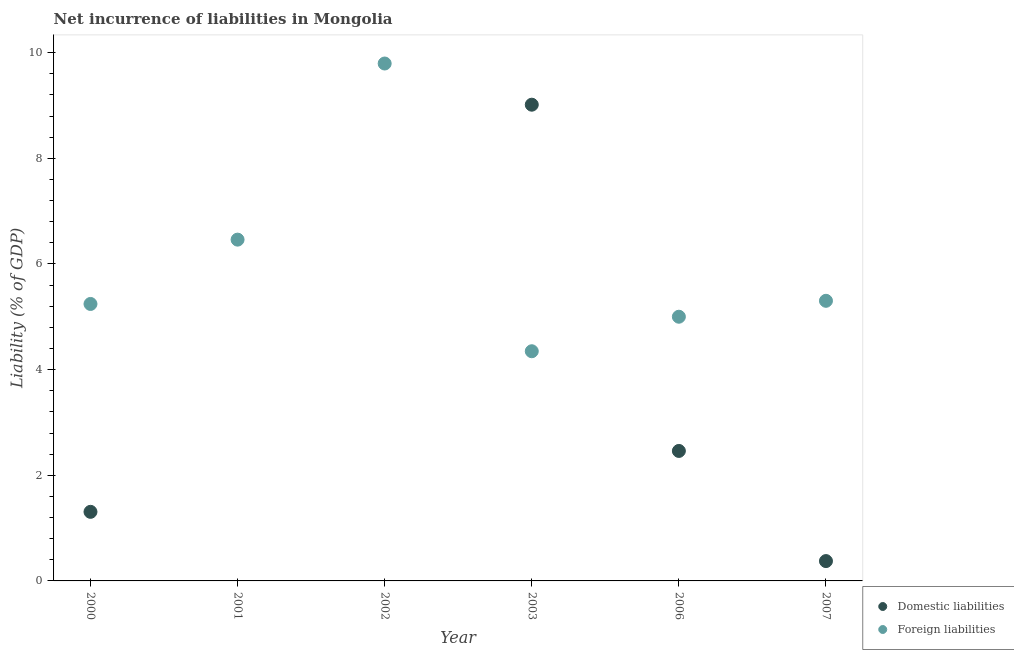How many different coloured dotlines are there?
Your answer should be very brief. 2. What is the incurrence of domestic liabilities in 2000?
Your answer should be very brief. 1.31. Across all years, what is the maximum incurrence of foreign liabilities?
Your answer should be compact. 9.79. What is the total incurrence of foreign liabilities in the graph?
Your answer should be compact. 36.15. What is the difference between the incurrence of domestic liabilities in 2003 and that in 2007?
Your answer should be compact. 8.64. What is the difference between the incurrence of domestic liabilities in 2003 and the incurrence of foreign liabilities in 2001?
Make the answer very short. 2.55. What is the average incurrence of domestic liabilities per year?
Your response must be concise. 2.19. In the year 2000, what is the difference between the incurrence of foreign liabilities and incurrence of domestic liabilities?
Make the answer very short. 3.94. In how many years, is the incurrence of foreign liabilities greater than 0.4 %?
Provide a succinct answer. 6. What is the ratio of the incurrence of foreign liabilities in 2000 to that in 2001?
Provide a succinct answer. 0.81. Is the incurrence of domestic liabilities in 2000 less than that in 2006?
Provide a short and direct response. Yes. What is the difference between the highest and the second highest incurrence of domestic liabilities?
Your response must be concise. 6.55. What is the difference between the highest and the lowest incurrence of domestic liabilities?
Provide a succinct answer. 9.02. In how many years, is the incurrence of domestic liabilities greater than the average incurrence of domestic liabilities taken over all years?
Provide a short and direct response. 2. Does the incurrence of foreign liabilities monotonically increase over the years?
Keep it short and to the point. No. Is the incurrence of foreign liabilities strictly greater than the incurrence of domestic liabilities over the years?
Give a very brief answer. No. What is the difference between two consecutive major ticks on the Y-axis?
Provide a short and direct response. 2. Does the graph contain any zero values?
Offer a very short reply. Yes. Where does the legend appear in the graph?
Offer a very short reply. Bottom right. How many legend labels are there?
Provide a short and direct response. 2. What is the title of the graph?
Offer a terse response. Net incurrence of liabilities in Mongolia. Does "Electricity" appear as one of the legend labels in the graph?
Offer a very short reply. No. What is the label or title of the Y-axis?
Offer a very short reply. Liability (% of GDP). What is the Liability (% of GDP) in Domestic liabilities in 2000?
Provide a succinct answer. 1.31. What is the Liability (% of GDP) in Foreign liabilities in 2000?
Give a very brief answer. 5.24. What is the Liability (% of GDP) in Foreign liabilities in 2001?
Your response must be concise. 6.46. What is the Liability (% of GDP) in Domestic liabilities in 2002?
Keep it short and to the point. 0. What is the Liability (% of GDP) of Foreign liabilities in 2002?
Keep it short and to the point. 9.79. What is the Liability (% of GDP) of Domestic liabilities in 2003?
Your response must be concise. 9.02. What is the Liability (% of GDP) of Foreign liabilities in 2003?
Give a very brief answer. 4.35. What is the Liability (% of GDP) in Domestic liabilities in 2006?
Give a very brief answer. 2.46. What is the Liability (% of GDP) in Foreign liabilities in 2006?
Your answer should be compact. 5. What is the Liability (% of GDP) in Domestic liabilities in 2007?
Make the answer very short. 0.38. What is the Liability (% of GDP) of Foreign liabilities in 2007?
Your answer should be very brief. 5.3. Across all years, what is the maximum Liability (% of GDP) of Domestic liabilities?
Your response must be concise. 9.02. Across all years, what is the maximum Liability (% of GDP) in Foreign liabilities?
Ensure brevity in your answer.  9.79. Across all years, what is the minimum Liability (% of GDP) in Domestic liabilities?
Provide a short and direct response. 0. Across all years, what is the minimum Liability (% of GDP) in Foreign liabilities?
Your response must be concise. 4.35. What is the total Liability (% of GDP) in Domestic liabilities in the graph?
Ensure brevity in your answer.  13.16. What is the total Liability (% of GDP) of Foreign liabilities in the graph?
Offer a very short reply. 36.15. What is the difference between the Liability (% of GDP) of Foreign liabilities in 2000 and that in 2001?
Your response must be concise. -1.22. What is the difference between the Liability (% of GDP) in Foreign liabilities in 2000 and that in 2002?
Make the answer very short. -4.55. What is the difference between the Liability (% of GDP) of Domestic liabilities in 2000 and that in 2003?
Offer a very short reply. -7.71. What is the difference between the Liability (% of GDP) of Foreign liabilities in 2000 and that in 2003?
Your answer should be very brief. 0.9. What is the difference between the Liability (% of GDP) of Domestic liabilities in 2000 and that in 2006?
Offer a very short reply. -1.15. What is the difference between the Liability (% of GDP) in Foreign liabilities in 2000 and that in 2006?
Ensure brevity in your answer.  0.24. What is the difference between the Liability (% of GDP) of Domestic liabilities in 2000 and that in 2007?
Provide a succinct answer. 0.93. What is the difference between the Liability (% of GDP) in Foreign liabilities in 2000 and that in 2007?
Your answer should be very brief. -0.06. What is the difference between the Liability (% of GDP) of Foreign liabilities in 2001 and that in 2002?
Your response must be concise. -3.33. What is the difference between the Liability (% of GDP) in Foreign liabilities in 2001 and that in 2003?
Offer a very short reply. 2.11. What is the difference between the Liability (% of GDP) of Foreign liabilities in 2001 and that in 2006?
Offer a very short reply. 1.46. What is the difference between the Liability (% of GDP) in Foreign liabilities in 2001 and that in 2007?
Your answer should be very brief. 1.16. What is the difference between the Liability (% of GDP) of Foreign liabilities in 2002 and that in 2003?
Make the answer very short. 5.45. What is the difference between the Liability (% of GDP) of Foreign liabilities in 2002 and that in 2006?
Make the answer very short. 4.79. What is the difference between the Liability (% of GDP) in Foreign liabilities in 2002 and that in 2007?
Ensure brevity in your answer.  4.49. What is the difference between the Liability (% of GDP) of Domestic liabilities in 2003 and that in 2006?
Give a very brief answer. 6.55. What is the difference between the Liability (% of GDP) in Foreign liabilities in 2003 and that in 2006?
Provide a short and direct response. -0.65. What is the difference between the Liability (% of GDP) of Domestic liabilities in 2003 and that in 2007?
Your answer should be very brief. 8.64. What is the difference between the Liability (% of GDP) of Foreign liabilities in 2003 and that in 2007?
Keep it short and to the point. -0.95. What is the difference between the Liability (% of GDP) in Domestic liabilities in 2006 and that in 2007?
Your response must be concise. 2.08. What is the difference between the Liability (% of GDP) of Foreign liabilities in 2006 and that in 2007?
Provide a succinct answer. -0.3. What is the difference between the Liability (% of GDP) in Domestic liabilities in 2000 and the Liability (% of GDP) in Foreign liabilities in 2001?
Your answer should be very brief. -5.15. What is the difference between the Liability (% of GDP) of Domestic liabilities in 2000 and the Liability (% of GDP) of Foreign liabilities in 2002?
Make the answer very short. -8.49. What is the difference between the Liability (% of GDP) in Domestic liabilities in 2000 and the Liability (% of GDP) in Foreign liabilities in 2003?
Offer a very short reply. -3.04. What is the difference between the Liability (% of GDP) in Domestic liabilities in 2000 and the Liability (% of GDP) in Foreign liabilities in 2006?
Give a very brief answer. -3.69. What is the difference between the Liability (% of GDP) of Domestic liabilities in 2000 and the Liability (% of GDP) of Foreign liabilities in 2007?
Ensure brevity in your answer.  -3.99. What is the difference between the Liability (% of GDP) in Domestic liabilities in 2003 and the Liability (% of GDP) in Foreign liabilities in 2006?
Your answer should be very brief. 4.01. What is the difference between the Liability (% of GDP) of Domestic liabilities in 2003 and the Liability (% of GDP) of Foreign liabilities in 2007?
Give a very brief answer. 3.71. What is the difference between the Liability (% of GDP) of Domestic liabilities in 2006 and the Liability (% of GDP) of Foreign liabilities in 2007?
Offer a very short reply. -2.84. What is the average Liability (% of GDP) of Domestic liabilities per year?
Your answer should be very brief. 2.19. What is the average Liability (% of GDP) of Foreign liabilities per year?
Your answer should be very brief. 6.03. In the year 2000, what is the difference between the Liability (% of GDP) of Domestic liabilities and Liability (% of GDP) of Foreign liabilities?
Provide a short and direct response. -3.94. In the year 2003, what is the difference between the Liability (% of GDP) in Domestic liabilities and Liability (% of GDP) in Foreign liabilities?
Your answer should be compact. 4.67. In the year 2006, what is the difference between the Liability (% of GDP) in Domestic liabilities and Liability (% of GDP) in Foreign liabilities?
Make the answer very short. -2.54. In the year 2007, what is the difference between the Liability (% of GDP) of Domestic liabilities and Liability (% of GDP) of Foreign liabilities?
Offer a very short reply. -4.93. What is the ratio of the Liability (% of GDP) in Foreign liabilities in 2000 to that in 2001?
Offer a terse response. 0.81. What is the ratio of the Liability (% of GDP) in Foreign liabilities in 2000 to that in 2002?
Provide a succinct answer. 0.54. What is the ratio of the Liability (% of GDP) in Domestic liabilities in 2000 to that in 2003?
Provide a short and direct response. 0.15. What is the ratio of the Liability (% of GDP) in Foreign liabilities in 2000 to that in 2003?
Offer a very short reply. 1.21. What is the ratio of the Liability (% of GDP) in Domestic liabilities in 2000 to that in 2006?
Give a very brief answer. 0.53. What is the ratio of the Liability (% of GDP) in Foreign liabilities in 2000 to that in 2006?
Give a very brief answer. 1.05. What is the ratio of the Liability (% of GDP) in Domestic liabilities in 2000 to that in 2007?
Ensure brevity in your answer.  3.48. What is the ratio of the Liability (% of GDP) of Foreign liabilities in 2001 to that in 2002?
Offer a very short reply. 0.66. What is the ratio of the Liability (% of GDP) in Foreign liabilities in 2001 to that in 2003?
Your response must be concise. 1.49. What is the ratio of the Liability (% of GDP) in Foreign liabilities in 2001 to that in 2006?
Your response must be concise. 1.29. What is the ratio of the Liability (% of GDP) in Foreign liabilities in 2001 to that in 2007?
Offer a very short reply. 1.22. What is the ratio of the Liability (% of GDP) in Foreign liabilities in 2002 to that in 2003?
Provide a short and direct response. 2.25. What is the ratio of the Liability (% of GDP) of Foreign liabilities in 2002 to that in 2006?
Provide a short and direct response. 1.96. What is the ratio of the Liability (% of GDP) in Foreign liabilities in 2002 to that in 2007?
Offer a very short reply. 1.85. What is the ratio of the Liability (% of GDP) of Domestic liabilities in 2003 to that in 2006?
Provide a short and direct response. 3.66. What is the ratio of the Liability (% of GDP) of Foreign liabilities in 2003 to that in 2006?
Your answer should be compact. 0.87. What is the ratio of the Liability (% of GDP) of Domestic liabilities in 2003 to that in 2007?
Your answer should be very brief. 24. What is the ratio of the Liability (% of GDP) in Foreign liabilities in 2003 to that in 2007?
Your answer should be compact. 0.82. What is the ratio of the Liability (% of GDP) of Domestic liabilities in 2006 to that in 2007?
Provide a short and direct response. 6.55. What is the ratio of the Liability (% of GDP) of Foreign liabilities in 2006 to that in 2007?
Ensure brevity in your answer.  0.94. What is the difference between the highest and the second highest Liability (% of GDP) in Domestic liabilities?
Keep it short and to the point. 6.55. What is the difference between the highest and the second highest Liability (% of GDP) of Foreign liabilities?
Keep it short and to the point. 3.33. What is the difference between the highest and the lowest Liability (% of GDP) of Domestic liabilities?
Your answer should be compact. 9.02. What is the difference between the highest and the lowest Liability (% of GDP) in Foreign liabilities?
Provide a short and direct response. 5.45. 